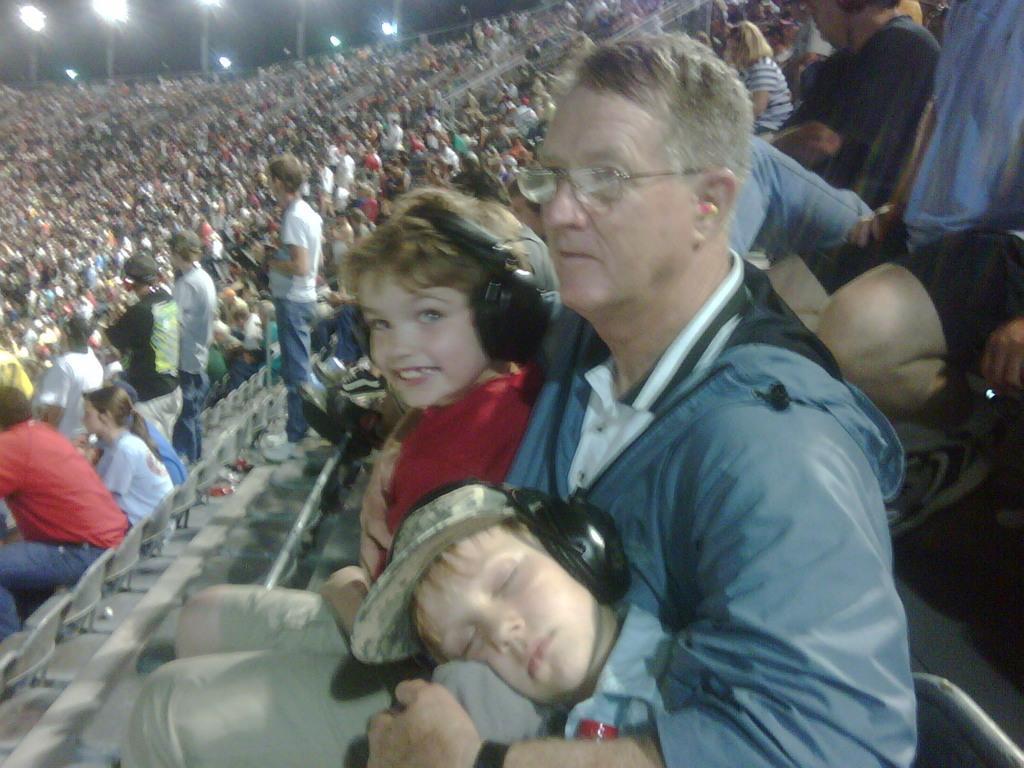How would you summarize this image in a sentence or two? In this image in the front there is a boy sleeping and there is a person holding kids in his arms and there is a person smiling. In the background there are persons standing and sitting and there are lights. 